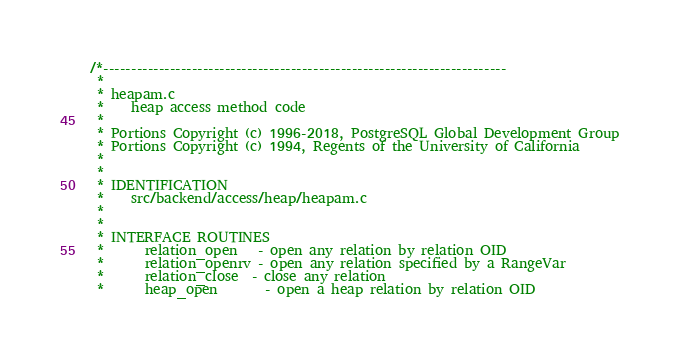Convert code to text. <code><loc_0><loc_0><loc_500><loc_500><_C_>/*-------------------------------------------------------------------------
 *
 * heapam.c
 *	  heap access method code
 *
 * Portions Copyright (c) 1996-2018, PostgreSQL Global Development Group
 * Portions Copyright (c) 1994, Regents of the University of California
 *
 *
 * IDENTIFICATION
 *	  src/backend/access/heap/heapam.c
 *
 *
 * INTERFACE ROUTINES
 *		relation_open	- open any relation by relation OID
 *		relation_openrv - open any relation specified by a RangeVar
 *		relation_close	- close any relation
 *		heap_open		- open a heap relation by relation OID</code> 